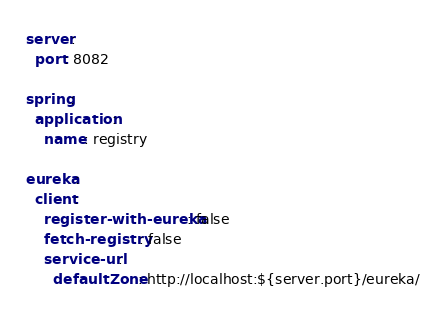Convert code to text. <code><loc_0><loc_0><loc_500><loc_500><_YAML_>server:
  port: 8082

spring:
  application:
    name: registry

eureka:
  client:
    register-with-eureka: false
    fetch-registry: false
    service-url:
      defaultZone: http://localhost:${server.port}/eureka/
</code> 